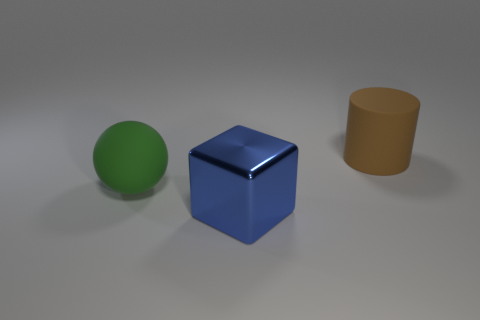Add 1 red cylinders. How many objects exist? 4 Subtract all spheres. How many objects are left? 2 Subtract all shiny things. Subtract all large green things. How many objects are left? 1 Add 1 big blocks. How many big blocks are left? 2 Add 1 spheres. How many spheres exist? 2 Subtract 0 green cylinders. How many objects are left? 3 